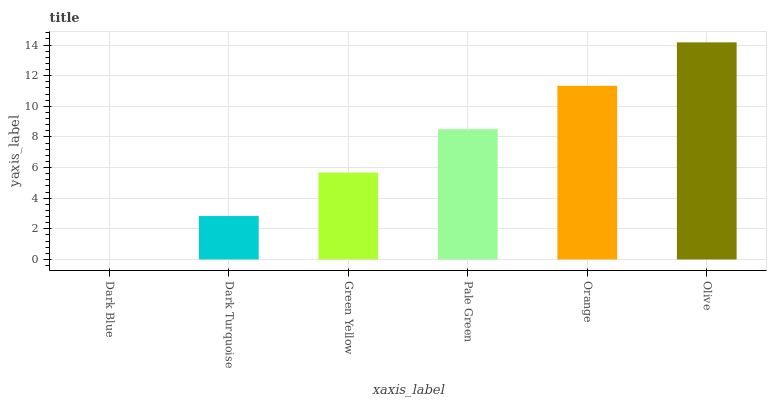Is Dark Blue the minimum?
Answer yes or no. Yes. Is Olive the maximum?
Answer yes or no. Yes. Is Dark Turquoise the minimum?
Answer yes or no. No. Is Dark Turquoise the maximum?
Answer yes or no. No. Is Dark Turquoise greater than Dark Blue?
Answer yes or no. Yes. Is Dark Blue less than Dark Turquoise?
Answer yes or no. Yes. Is Dark Blue greater than Dark Turquoise?
Answer yes or no. No. Is Dark Turquoise less than Dark Blue?
Answer yes or no. No. Is Pale Green the high median?
Answer yes or no. Yes. Is Green Yellow the low median?
Answer yes or no. Yes. Is Orange the high median?
Answer yes or no. No. Is Pale Green the low median?
Answer yes or no. No. 